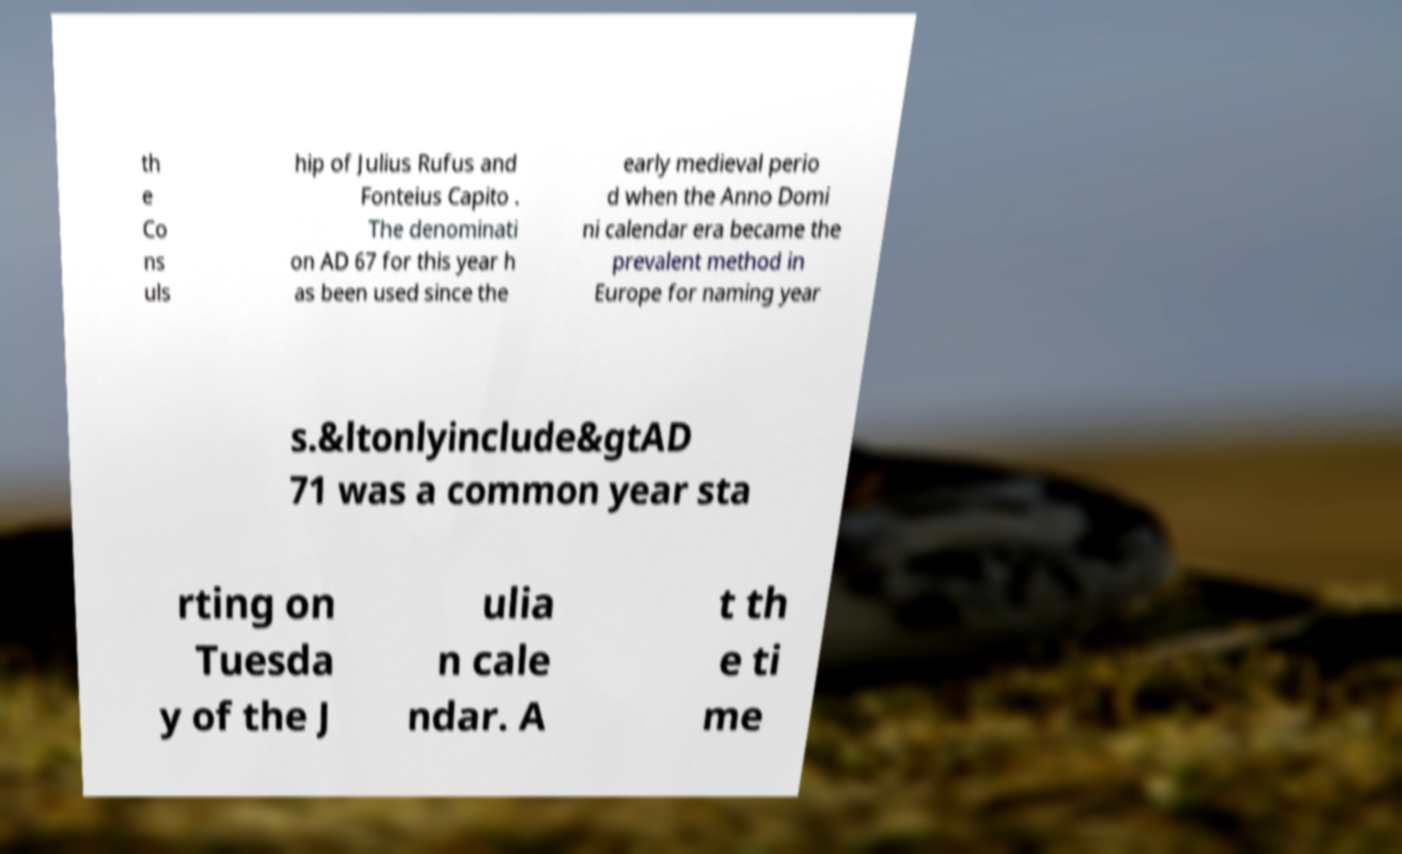There's text embedded in this image that I need extracted. Can you transcribe it verbatim? th e Co ns uls hip of Julius Rufus and Fonteius Capito . The denominati on AD 67 for this year h as been used since the early medieval perio d when the Anno Domi ni calendar era became the prevalent method in Europe for naming year s.&ltonlyinclude&gtAD 71 was a common year sta rting on Tuesda y of the J ulia n cale ndar. A t th e ti me 